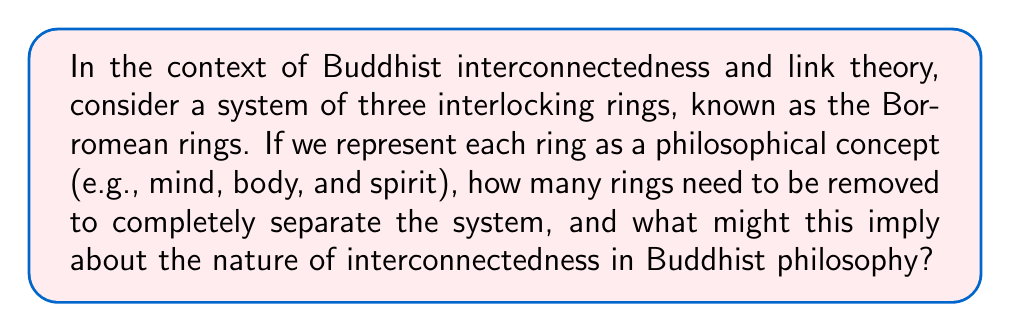What is the answer to this math problem? To approach this problem, let's consider the properties of Borromean rings from a knot theory perspective and relate them to Buddhist philosophy:

1. Borromean rings are a set of three topological circles which are linked and form a Brunnian link.

2. A key property of Borromean rings is that they are inseparable as a whole, but removing any single ring allows the other two to fall apart. Mathematically:

   $$\text{Link}(R_1, R_2, R_3) \neq 0$$
   $$\text{Link}(R_1, R_2) = \text{Link}(R_2, R_3) = \text{Link}(R_3, R_1) = 0$$

   Where $\text{Link}(...)$ represents the linking number.

3. In the context of Buddhist philosophy, we can interpret each ring as a fundamental aspect of existence (mind, body, spirit). The Borromean property suggests that these aspects are interdependent.

4. To separate the system, we need to remove only one ring. This can be represented as:

   $$\text{System} - R_i = \text{Unlinked}(R_j, R_k)$$

   Where $i, j, k$ are distinct indices from {1, 2, 3}.

5. This property aligns with the Buddhist concept of interconnectedness (pratītyasamutpāda), which posits that all phenomena are interconnected and nothing exists in isolation.

6. The fact that removing one ring causes the entire system to fall apart reflects the Buddhist idea that changing one aspect of reality affects the whole, emphasizing the delicate balance of existence.

From a philosophical perspective, this mathematical property of Borromean rings provides a powerful metaphor for the Buddhist view of reality as a web of interconnected phenomena, where each element is crucial for the integrity of the whole.
Answer: 1 ring 